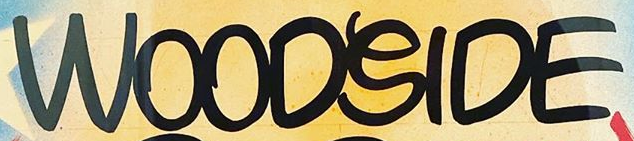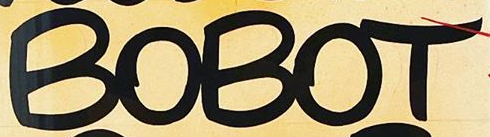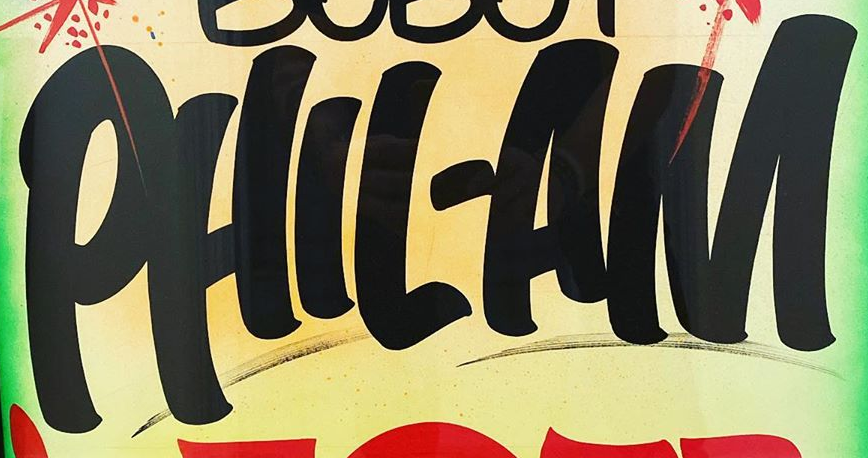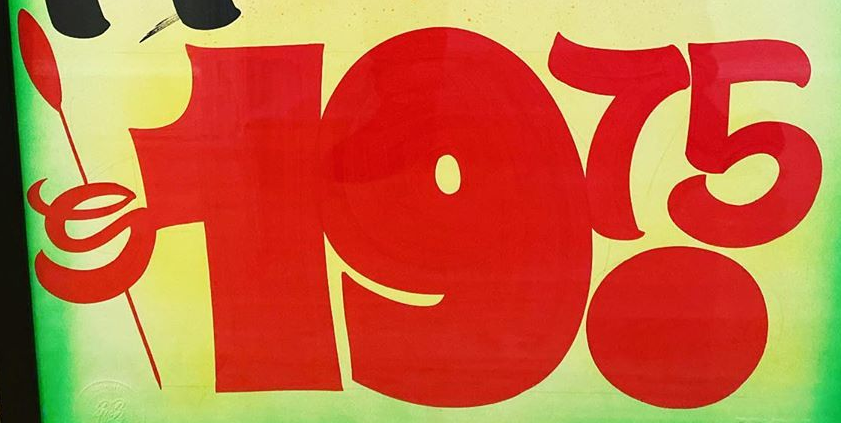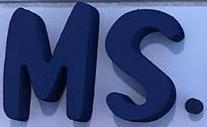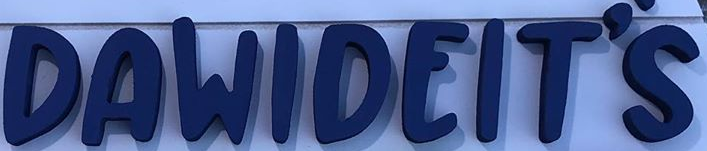Read the text from these images in sequence, separated by a semicolon. WOODSIDE; BOBOT; PHIL-AM; $19.75; MS.; DAWIDEIT'S 